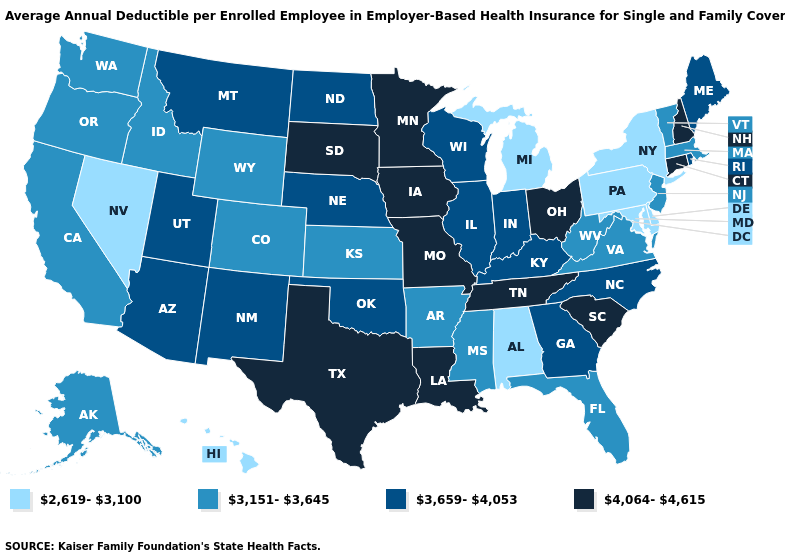Does New York have the lowest value in the Northeast?
Quick response, please. Yes. What is the value of Massachusetts?
Answer briefly. 3,151-3,645. Name the states that have a value in the range 3,659-4,053?
Quick response, please. Arizona, Georgia, Illinois, Indiana, Kentucky, Maine, Montana, Nebraska, New Mexico, North Carolina, North Dakota, Oklahoma, Rhode Island, Utah, Wisconsin. Name the states that have a value in the range 4,064-4,615?
Write a very short answer. Connecticut, Iowa, Louisiana, Minnesota, Missouri, New Hampshire, Ohio, South Carolina, South Dakota, Tennessee, Texas. Does the map have missing data?
Keep it brief. No. Does Kansas have the lowest value in the MidWest?
Short answer required. No. Name the states that have a value in the range 3,151-3,645?
Quick response, please. Alaska, Arkansas, California, Colorado, Florida, Idaho, Kansas, Massachusetts, Mississippi, New Jersey, Oregon, Vermont, Virginia, Washington, West Virginia, Wyoming. Does South Dakota have the highest value in the USA?
Short answer required. Yes. Name the states that have a value in the range 4,064-4,615?
Write a very short answer. Connecticut, Iowa, Louisiana, Minnesota, Missouri, New Hampshire, Ohio, South Carolina, South Dakota, Tennessee, Texas. How many symbols are there in the legend?
Concise answer only. 4. Is the legend a continuous bar?
Short answer required. No. What is the value of Tennessee?
Answer briefly. 4,064-4,615. What is the lowest value in the West?
Concise answer only. 2,619-3,100. Does Tennessee have the lowest value in the USA?
Answer briefly. No. Which states have the highest value in the USA?
Answer briefly. Connecticut, Iowa, Louisiana, Minnesota, Missouri, New Hampshire, Ohio, South Carolina, South Dakota, Tennessee, Texas. 